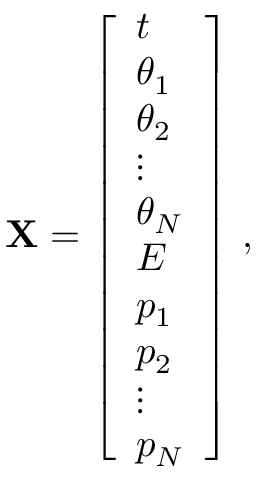Convert formula to latex. <formula><loc_0><loc_0><loc_500><loc_500>X = \left [ \begin{array} { l } { t } \\ { \theta _ { 1 } } \\ { \theta _ { 2 } } \\ { \vdots } \\ { \theta _ { N } } \\ { E } \\ { p _ { 1 } } \\ { p _ { 2 } } \\ { \vdots } \\ { p _ { N } } \end{array} \right ] \, ,</formula> 